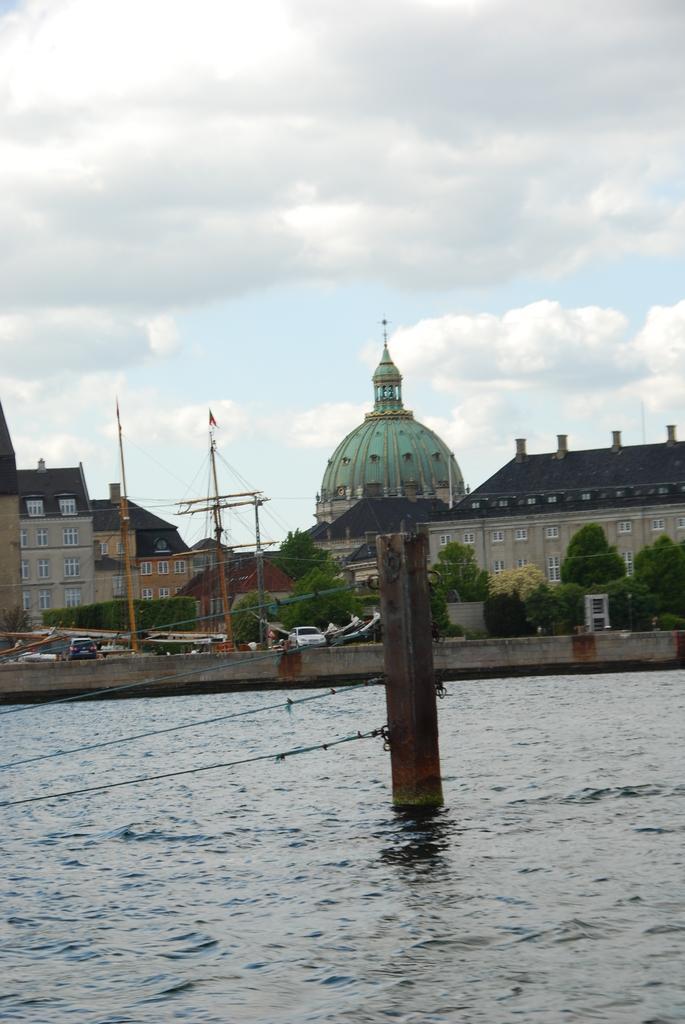How would you summarize this image in a sentence or two? In this picture, there is a river at the bottom. In the river, there is a pole with ropes. In the center, there are castles, buildings, trees, vehicles etc. On the top, there is a sky with clouds. 